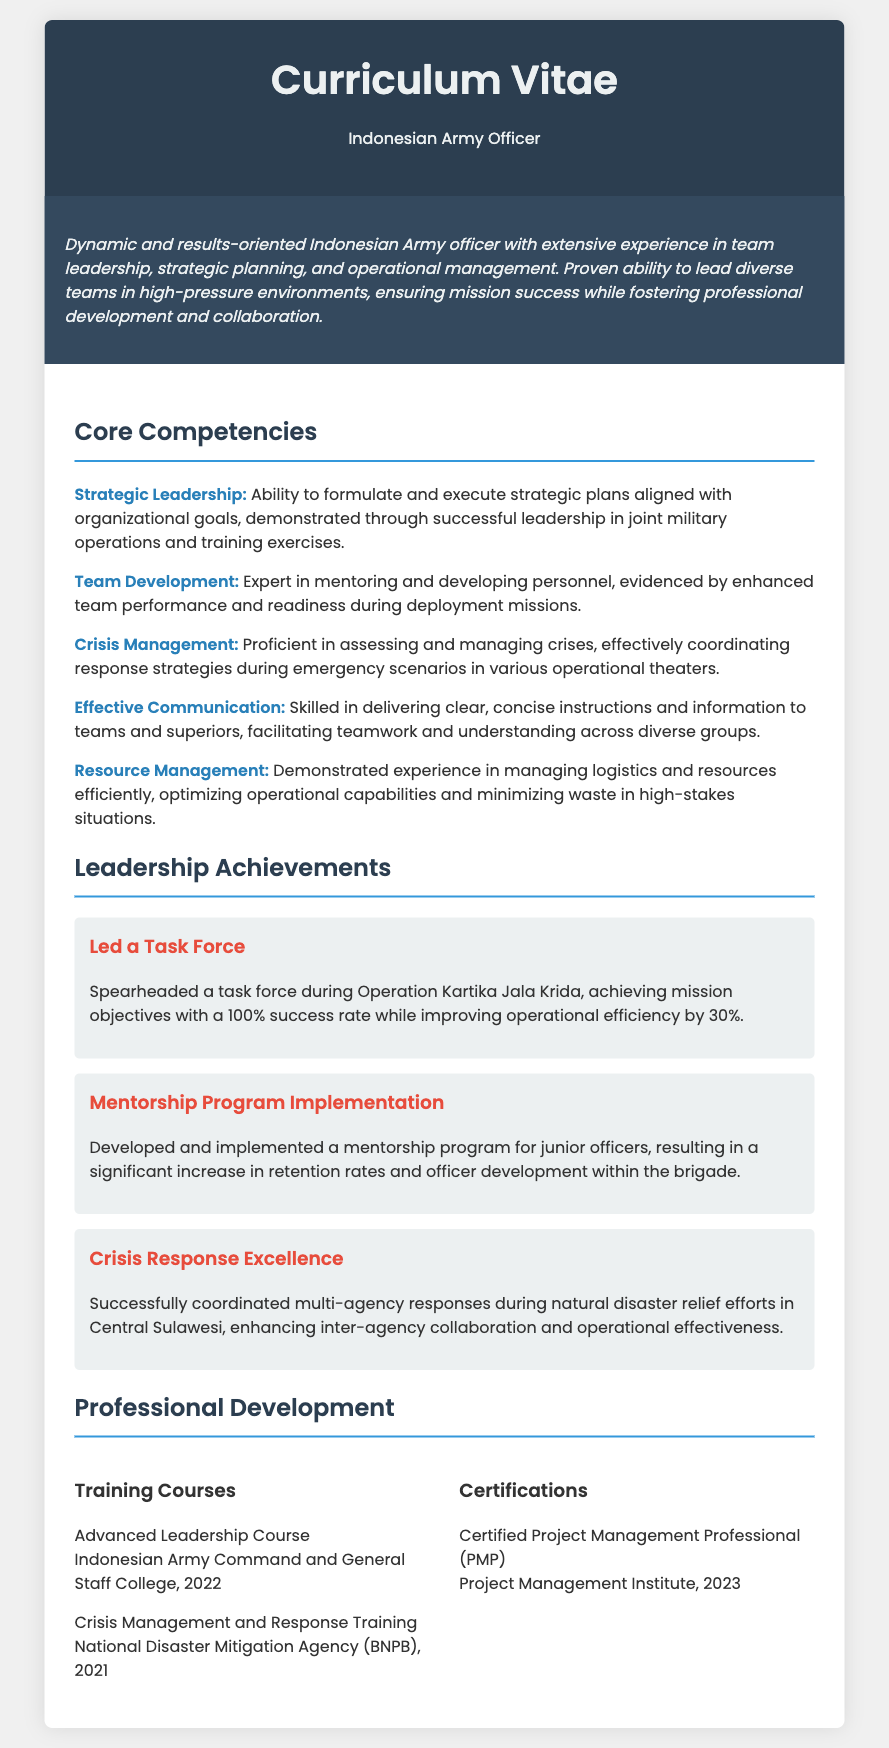What is the primary role of the individual? The document states that the individual is an "Indonesian Army Officer."
Answer: Indonesian Army Officer In which year was the Advanced Leadership Course completed? The document lists the completion date as "2022" next to the course title.
Answer: 2022 What achievement involved Operation Kartika Jala Krida? The individual led a task force during this operation, achieving "mission objectives with a 100% success rate."
Answer: Led a Task Force What is the focus of the mentorship program developed? The program aimed for "junior officers," addressing their retention and development.
Answer: Junior officers How much did operational efficiency improve during the task force leadership? The document states that it improved by "30%."
Answer: 30% What is one key personal trait highlighted in the executive summary? The executive summary describes the individual as "dynamic and results-oriented."
Answer: Dynamic and results-oriented Which organization provided crisis management training in 2021? The document mentions "National Disaster Mitigation Agency (BNPB)" for the training course.
Answer: National Disaster Mitigation Agency (BNPB) What certification was obtained in 2023? The document indicates a certification in "Project Management Professional (PMP)."
Answer: Project Management Professional (PMP) What does the individual excel in, according to their core competencies? They are an "Expert in mentoring and developing personnel."
Answer: Expert in mentoring and developing personnel 